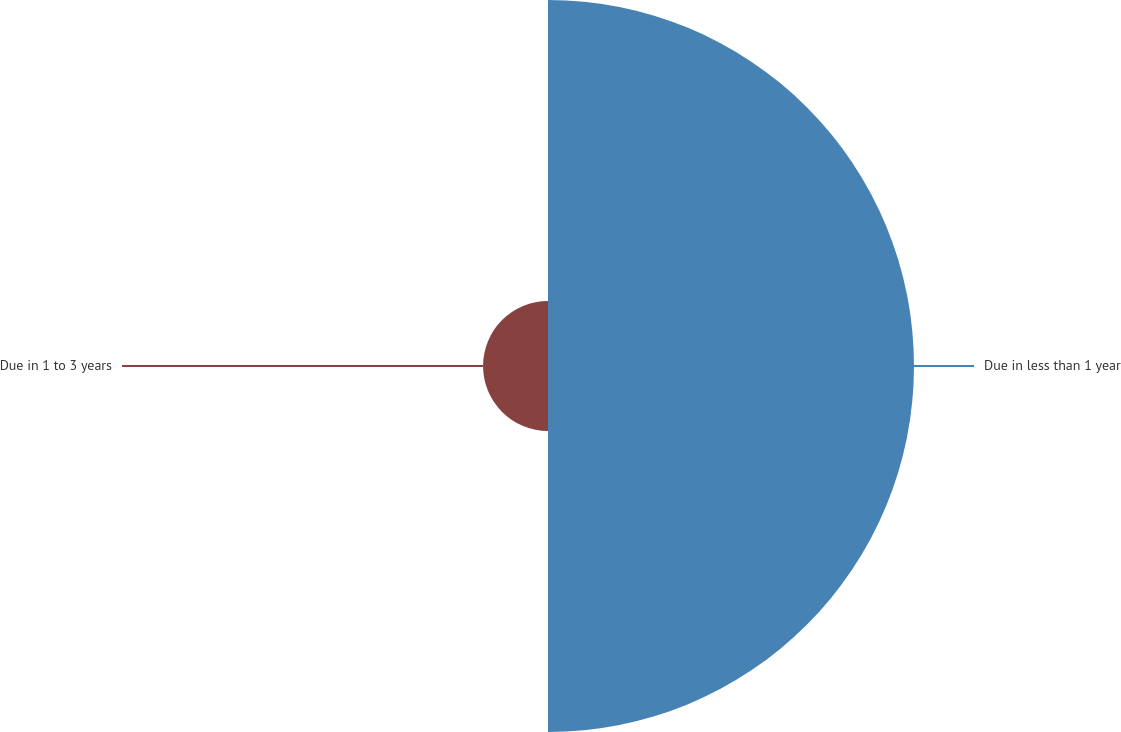Convert chart to OTSL. <chart><loc_0><loc_0><loc_500><loc_500><pie_chart><fcel>Due in less than 1 year<fcel>Due in 1 to 3 years<nl><fcel>84.93%<fcel>15.07%<nl></chart> 